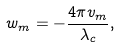Convert formula to latex. <formula><loc_0><loc_0><loc_500><loc_500>w _ { m } = - \frac { 4 \pi v _ { m } } { \lambda _ { c } } ,</formula> 